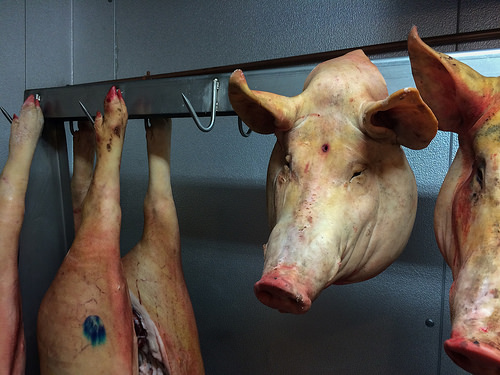<image>
Can you confirm if the hoof is next to the hook? Yes. The hoof is positioned adjacent to the hook, located nearby in the same general area. 